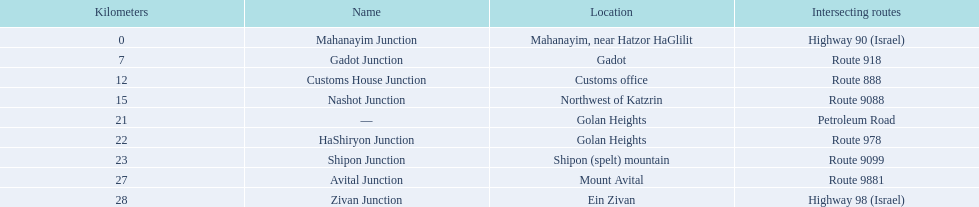What are all the crossing names? Mahanayim Junction, Gadot Junction, Customs House Junction, Nashot Junction, —, HaShiryon Junction, Shipon Junction, Avital Junction, Zivan Junction. What are their distances in kilometers? 0, 7, 12, 15, 21, 22, 23, 27, 28. Between shipon and avital, which one is closer to nashot? Shipon Junction. 